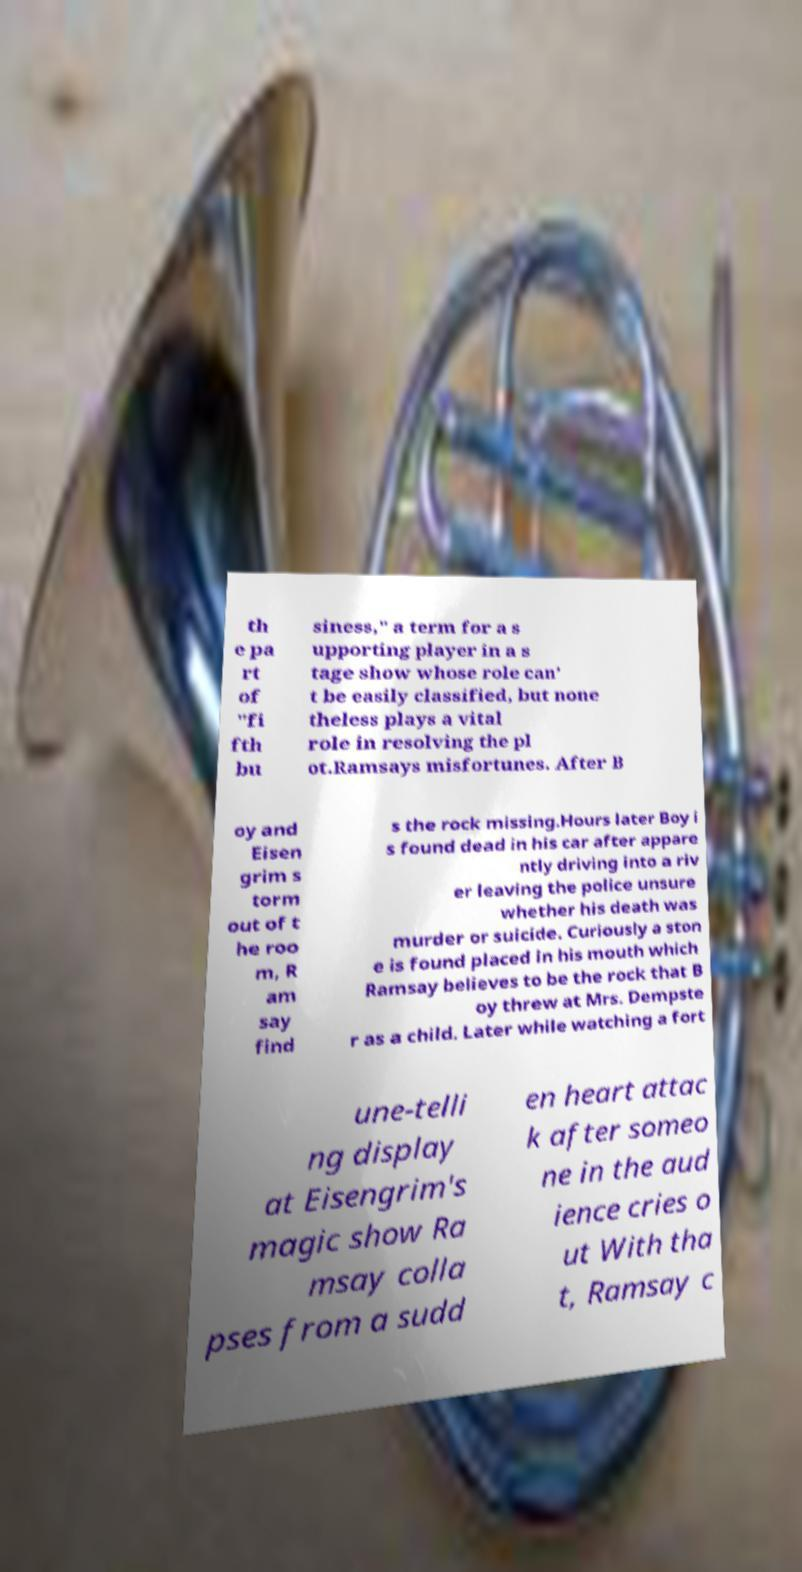There's text embedded in this image that I need extracted. Can you transcribe it verbatim? th e pa rt of "fi fth bu siness," a term for a s upporting player in a s tage show whose role can’ t be easily classified, but none theless plays a vital role in resolving the pl ot.Ramsays misfortunes. After B oy and Eisen grim s torm out of t he roo m, R am say find s the rock missing.Hours later Boy i s found dead in his car after appare ntly driving into a riv er leaving the police unsure whether his death was murder or suicide. Curiously a ston e is found placed in his mouth which Ramsay believes to be the rock that B oy threw at Mrs. Dempste r as a child. Later while watching a fort une-telli ng display at Eisengrim's magic show Ra msay colla pses from a sudd en heart attac k after someo ne in the aud ience cries o ut With tha t, Ramsay c 